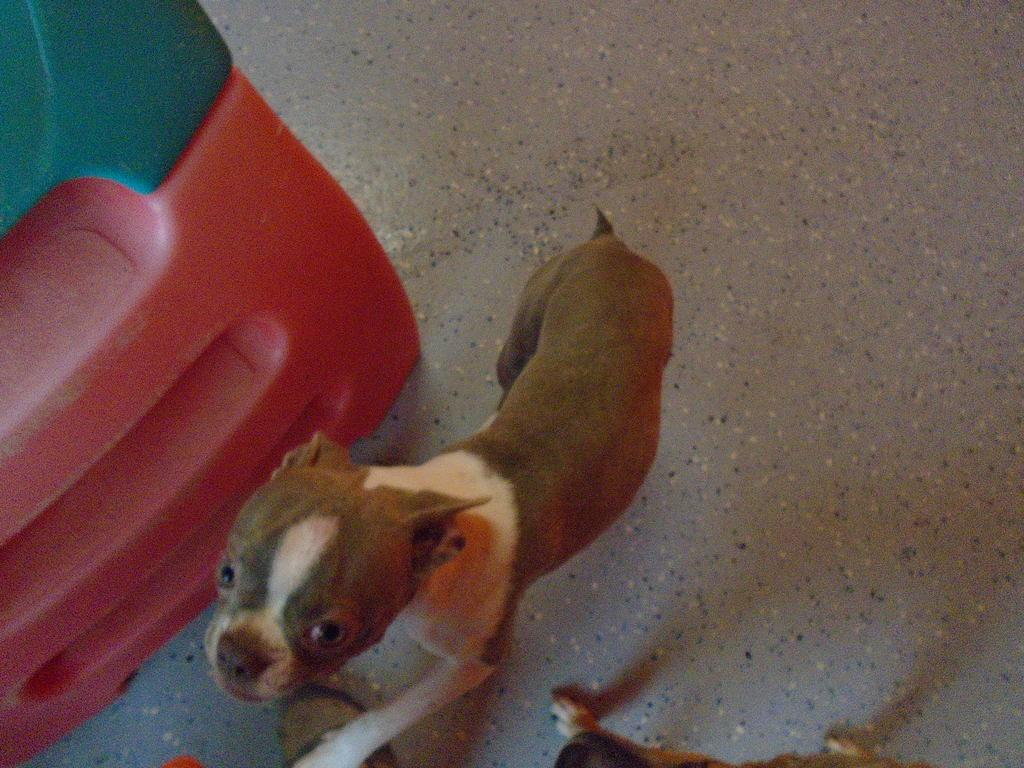What animal is on the floor in the image? There is a dog on the floor in the image. What can be seen on the left side of the image? There is an object on the left side of the image. What colors are present on the object? The object has red and green colors. What type of jeans is the dog wearing in the image? Dogs do not wear jeans, and there is no mention of jeans in the image. 